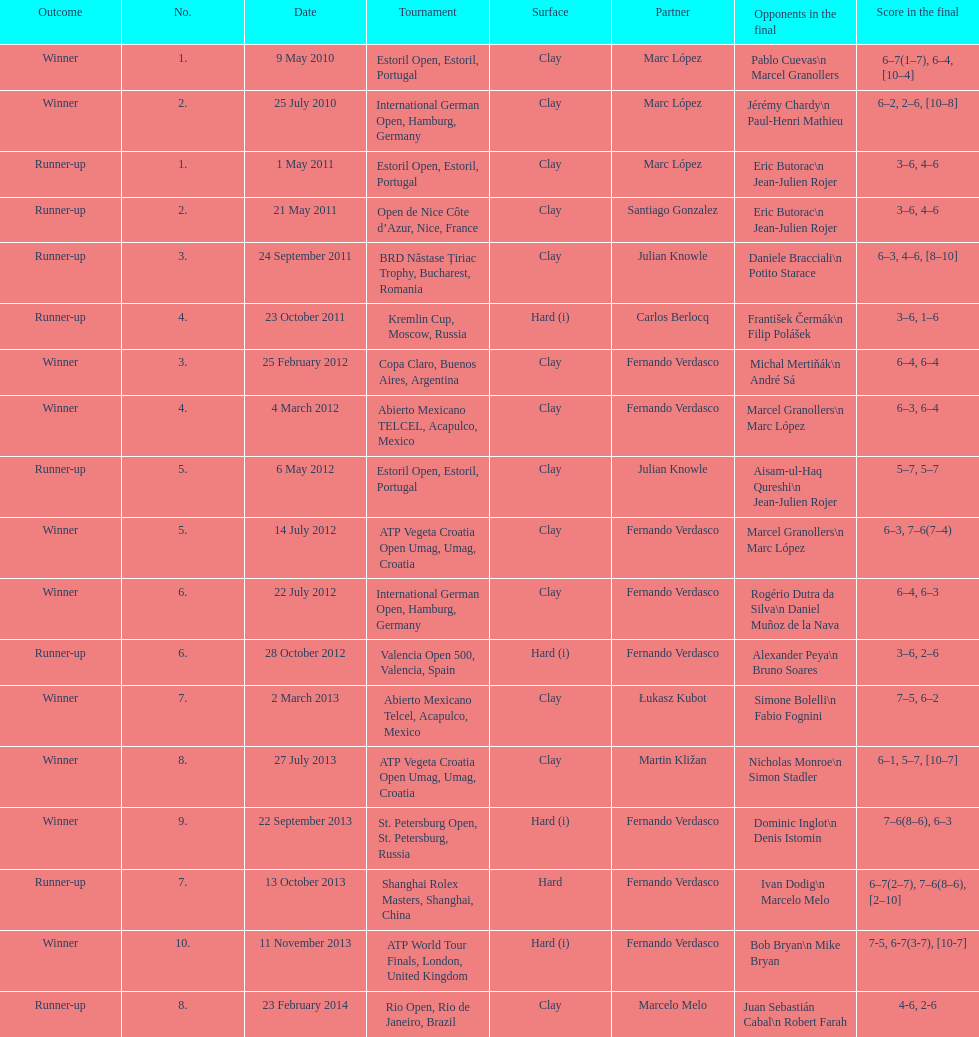In this player's career to date, how many championships have they claimed? 10. 